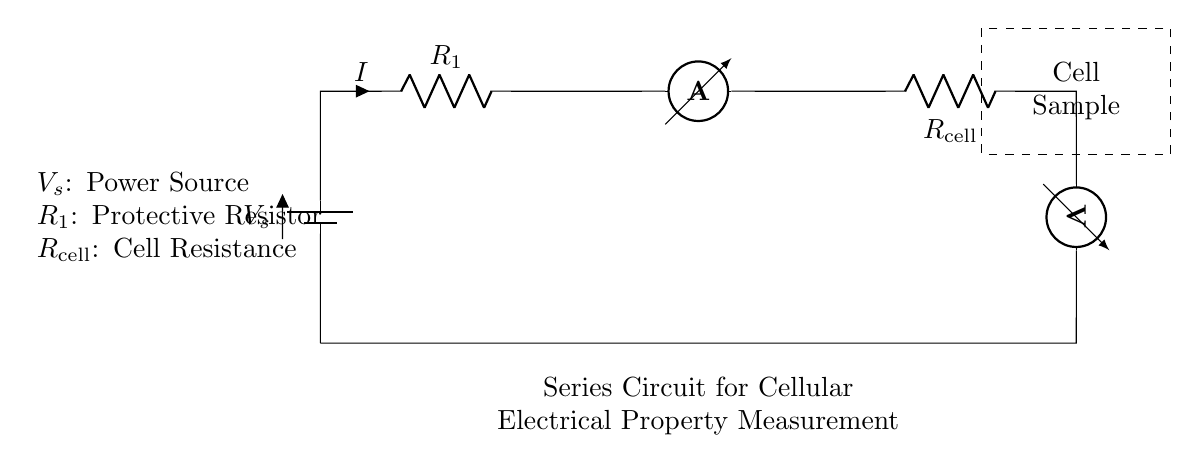What is the power source in the circuit? The power source is represented by the battery symbol labeled V_s. This indicates that it provides the required voltage for the circuit.
Answer: V_s What component is used to measure current in this circuit? The ammeter is the component used to measure current, as indicated by its label in the diagram. It is placed in series to measure the same current flowing through the circuit.
Answer: Ammeter What is the resistance value of the cell? The resistance of the cell is represented by the symbol labeled R_cell in the circuit. This indicates it is the part of the circuit that corresponds to the cellular electrical properties being studied.
Answer: R_cell How are the components connected in this circuit? The components are connected in series, meaning that they are arranged one after another in a single pathway for the current to flow. The current that flows through one component also flows through the others sequentially.
Answer: Series What happens to current if the resistance of the cell increases? If the resistance of the cell increases, the total current in the circuit decreases due to Ohm's law, which states that current is inversely proportional to resistance when voltage is constant. Hence, higher resistance results in lower current.
Answer: Decreases What is the role of the protective resistor R_1 in this circuit? R_1 serves to protect the circuit and components from excessive current which may occur during operation. By limiting the current, it ensures the components do not suffer damage and enables more accurate measurements of the cell properties.
Answer: Protection What is the relationship between voltage, current, and resistance in this series circuit? In a series circuit, the total voltage is equal to the sum of the voltage drops across each component, and the current is the same through all components. According to Ohm's law, voltage = current multiplied by resistance.
Answer: Ohm's law 